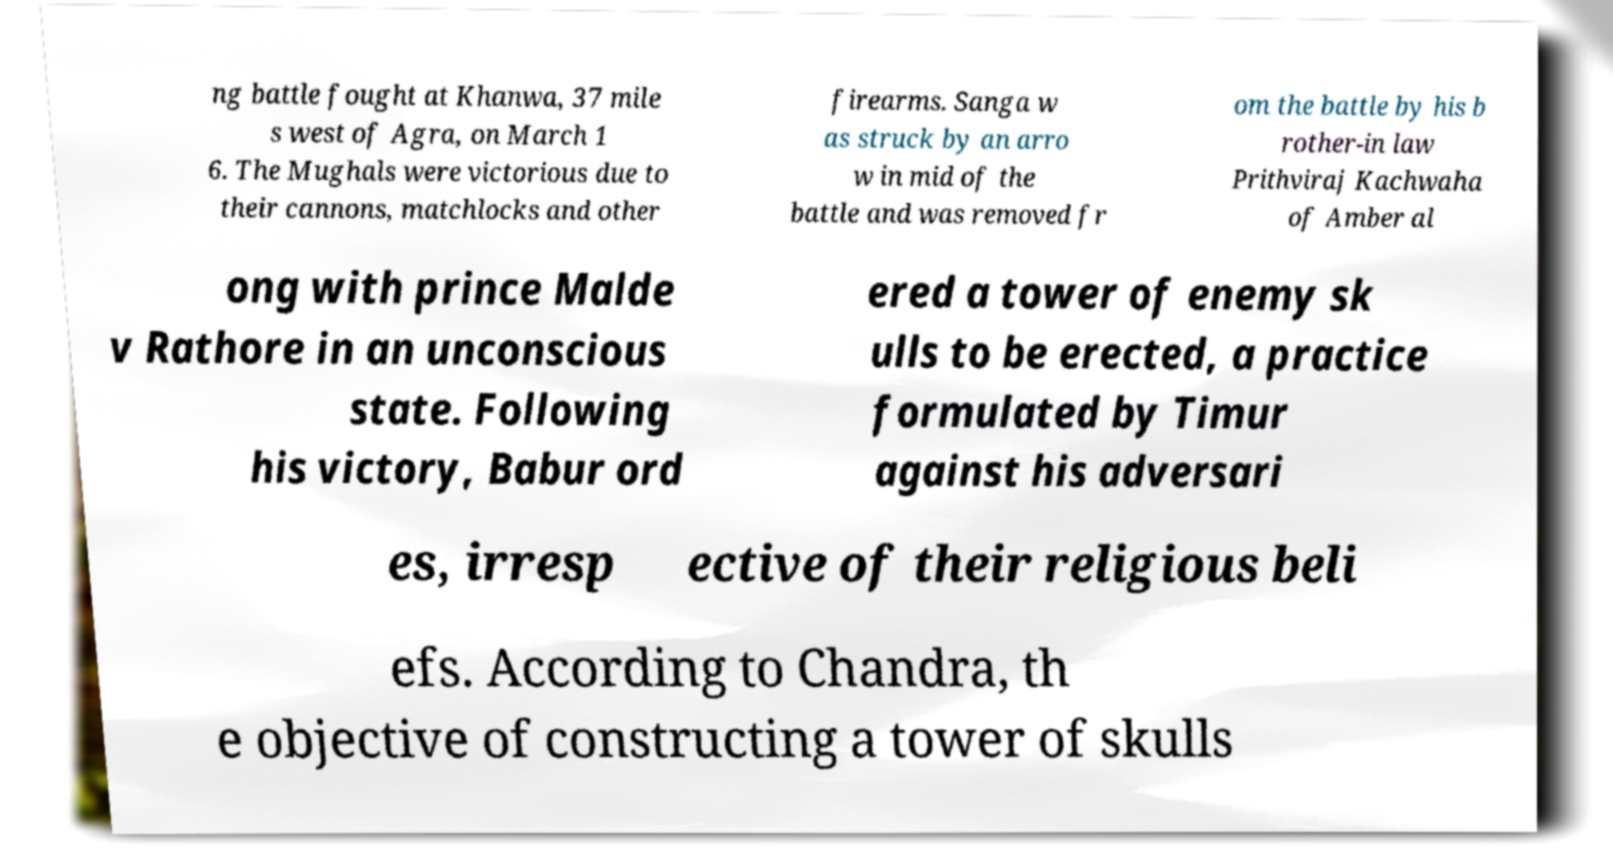There's text embedded in this image that I need extracted. Can you transcribe it verbatim? ng battle fought at Khanwa, 37 mile s west of Agra, on March 1 6. The Mughals were victorious due to their cannons, matchlocks and other firearms. Sanga w as struck by an arro w in mid of the battle and was removed fr om the battle by his b rother-in law Prithviraj Kachwaha of Amber al ong with prince Malde v Rathore in an unconscious state. Following his victory, Babur ord ered a tower of enemy sk ulls to be erected, a practice formulated by Timur against his adversari es, irresp ective of their religious beli efs. According to Chandra, th e objective of constructing a tower of skulls 